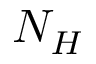<formula> <loc_0><loc_0><loc_500><loc_500>N _ { H }</formula> 